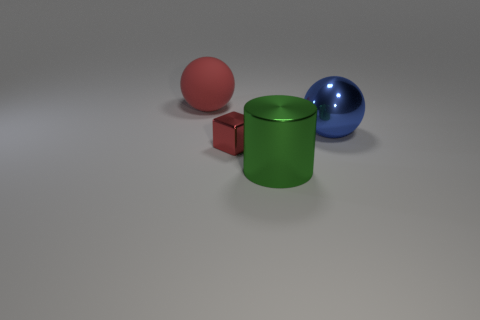Add 3 rubber things. How many objects exist? 7 Subtract all cylinders. How many objects are left? 3 Add 1 green metallic cylinders. How many green metallic cylinders are left? 2 Add 1 large gray metal cubes. How many large gray metal cubes exist? 1 Subtract 0 brown cylinders. How many objects are left? 4 Subtract all red rubber balls. Subtract all small brown metallic balls. How many objects are left? 3 